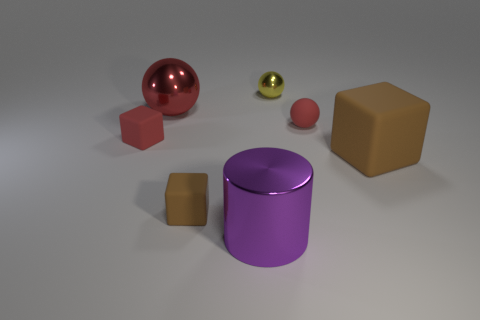The red thing that is the same material as the tiny yellow ball is what shape?
Your answer should be compact. Sphere. What number of green things are either rubber spheres or tiny shiny spheres?
Your answer should be very brief. 0. Are there any tiny rubber balls to the right of the red shiny thing?
Offer a very short reply. Yes. Is the shape of the big thing that is to the left of the large purple thing the same as the small matte thing that is behind the tiny red matte cube?
Provide a succinct answer. Yes. There is another tiny object that is the same shape as the yellow object; what is its material?
Provide a short and direct response. Rubber. What number of cylinders are either tiny brown matte things or purple rubber things?
Offer a very short reply. 0. What number of other objects have the same material as the tiny yellow object?
Ensure brevity in your answer.  2. Is the red thing right of the yellow metal thing made of the same material as the cube to the right of the large purple cylinder?
Offer a very short reply. Yes. What number of rubber things are on the right side of the cube behind the brown rubber cube to the right of the red rubber sphere?
Offer a very short reply. 3. Is the color of the metallic thing in front of the red rubber block the same as the tiny object that is behind the tiny red matte ball?
Your response must be concise. No. 